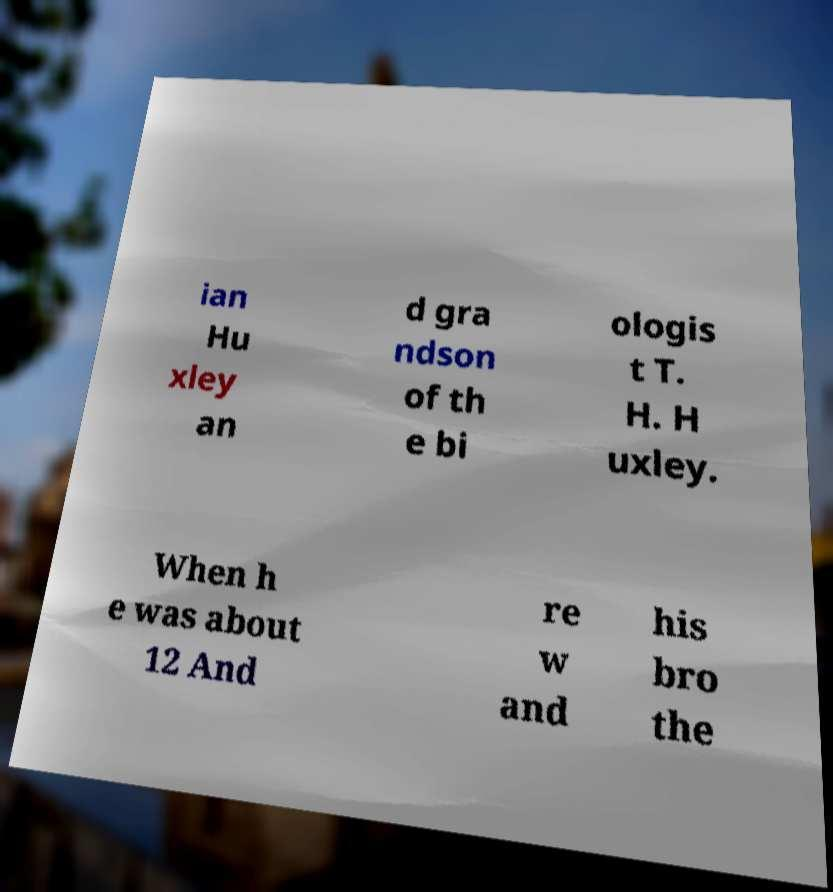Could you extract and type out the text from this image? ian Hu xley an d gra ndson of th e bi ologis t T. H. H uxley. When h e was about 12 And re w and his bro the 